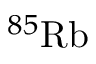<formula> <loc_0><loc_0><loc_500><loc_500>^ { 8 5 } R b</formula> 